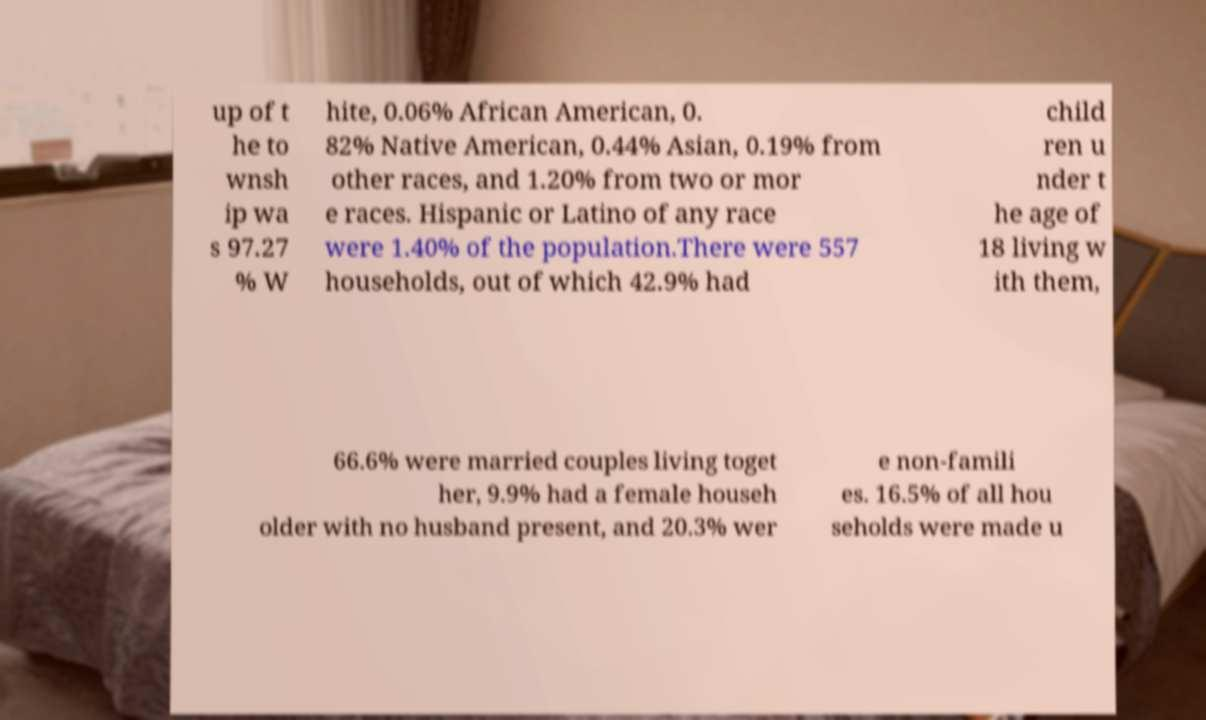Please read and relay the text visible in this image. What does it say? up of t he to wnsh ip wa s 97.27 % W hite, 0.06% African American, 0. 82% Native American, 0.44% Asian, 0.19% from other races, and 1.20% from two or mor e races. Hispanic or Latino of any race were 1.40% of the population.There were 557 households, out of which 42.9% had child ren u nder t he age of 18 living w ith them, 66.6% were married couples living toget her, 9.9% had a female househ older with no husband present, and 20.3% wer e non-famili es. 16.5% of all hou seholds were made u 